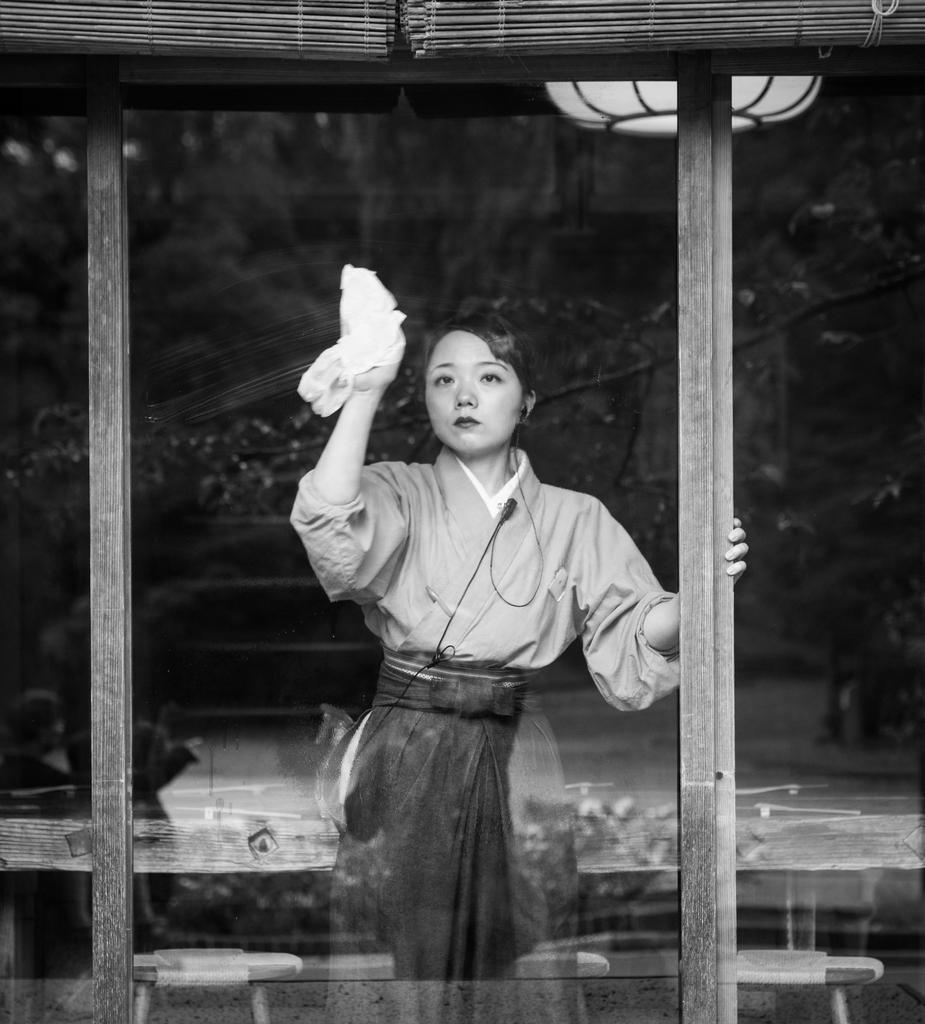Describe this image in one or two sentences. In this picture we can see a woman standing and holding a cloth with her hand and in the background we can see tree and light. 